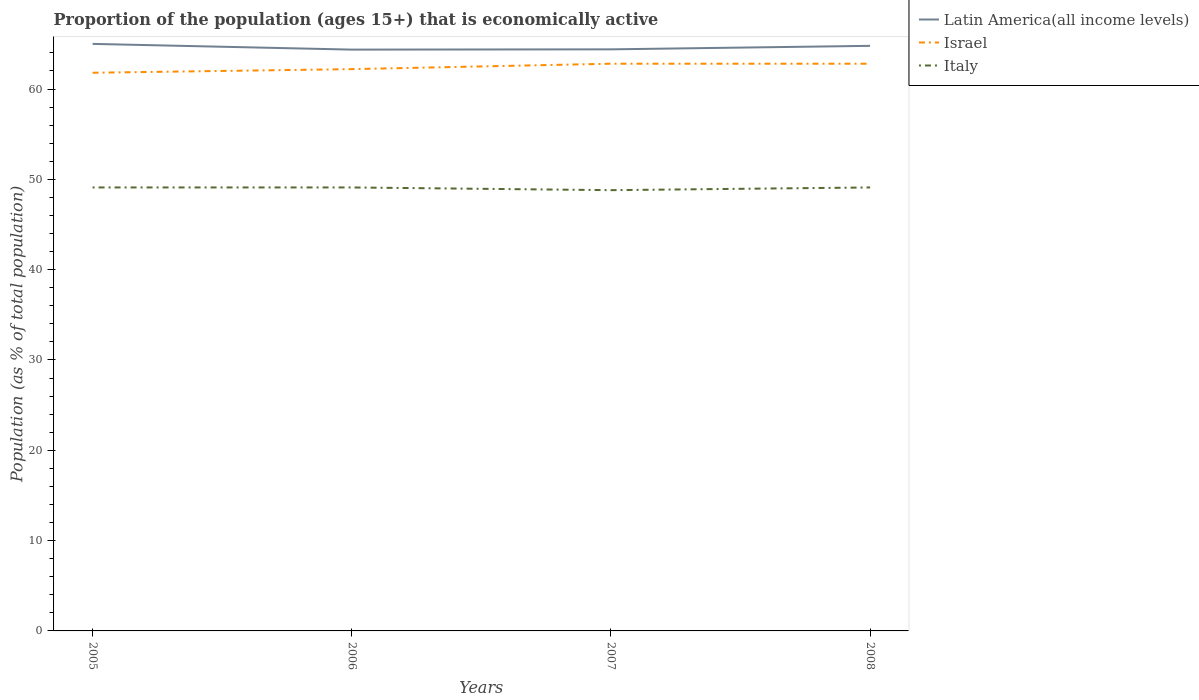Is the number of lines equal to the number of legend labels?
Offer a terse response. Yes. Across all years, what is the maximum proportion of the population that is economically active in Latin America(all income levels)?
Give a very brief answer. 64.36. In which year was the proportion of the population that is economically active in Italy maximum?
Give a very brief answer. 2007. What is the total proportion of the population that is economically active in Israel in the graph?
Give a very brief answer. -0.4. What is the difference between the highest and the second highest proportion of the population that is economically active in Latin America(all income levels)?
Make the answer very short. 0.63. What is the difference between the highest and the lowest proportion of the population that is economically active in Israel?
Provide a short and direct response. 2. What is the difference between two consecutive major ticks on the Y-axis?
Give a very brief answer. 10. Does the graph contain grids?
Your response must be concise. No. Where does the legend appear in the graph?
Give a very brief answer. Top right. How many legend labels are there?
Your answer should be compact. 3. What is the title of the graph?
Your response must be concise. Proportion of the population (ages 15+) that is economically active. Does "Moldova" appear as one of the legend labels in the graph?
Offer a terse response. No. What is the label or title of the Y-axis?
Ensure brevity in your answer.  Population (as % of total population). What is the Population (as % of total population) in Latin America(all income levels) in 2005?
Ensure brevity in your answer.  64.99. What is the Population (as % of total population) in Israel in 2005?
Your response must be concise. 61.8. What is the Population (as % of total population) of Italy in 2005?
Make the answer very short. 49.1. What is the Population (as % of total population) of Latin America(all income levels) in 2006?
Provide a short and direct response. 64.36. What is the Population (as % of total population) of Israel in 2006?
Offer a very short reply. 62.2. What is the Population (as % of total population) in Italy in 2006?
Keep it short and to the point. 49.1. What is the Population (as % of total population) of Latin America(all income levels) in 2007?
Provide a succinct answer. 64.39. What is the Population (as % of total population) in Israel in 2007?
Offer a very short reply. 62.8. What is the Population (as % of total population) in Italy in 2007?
Ensure brevity in your answer.  48.8. What is the Population (as % of total population) in Latin America(all income levels) in 2008?
Make the answer very short. 64.78. What is the Population (as % of total population) in Israel in 2008?
Keep it short and to the point. 62.8. What is the Population (as % of total population) of Italy in 2008?
Your response must be concise. 49.1. Across all years, what is the maximum Population (as % of total population) of Latin America(all income levels)?
Make the answer very short. 64.99. Across all years, what is the maximum Population (as % of total population) in Israel?
Your answer should be very brief. 62.8. Across all years, what is the maximum Population (as % of total population) in Italy?
Your answer should be very brief. 49.1. Across all years, what is the minimum Population (as % of total population) of Latin America(all income levels)?
Keep it short and to the point. 64.36. Across all years, what is the minimum Population (as % of total population) of Israel?
Ensure brevity in your answer.  61.8. Across all years, what is the minimum Population (as % of total population) in Italy?
Your answer should be compact. 48.8. What is the total Population (as % of total population) in Latin America(all income levels) in the graph?
Provide a succinct answer. 258.53. What is the total Population (as % of total population) of Israel in the graph?
Keep it short and to the point. 249.6. What is the total Population (as % of total population) in Italy in the graph?
Make the answer very short. 196.1. What is the difference between the Population (as % of total population) of Latin America(all income levels) in 2005 and that in 2006?
Give a very brief answer. 0.63. What is the difference between the Population (as % of total population) in Latin America(all income levels) in 2005 and that in 2007?
Ensure brevity in your answer.  0.6. What is the difference between the Population (as % of total population) in Latin America(all income levels) in 2005 and that in 2008?
Your response must be concise. 0.22. What is the difference between the Population (as % of total population) in Latin America(all income levels) in 2006 and that in 2007?
Ensure brevity in your answer.  -0.03. What is the difference between the Population (as % of total population) in Israel in 2006 and that in 2007?
Provide a short and direct response. -0.6. What is the difference between the Population (as % of total population) of Latin America(all income levels) in 2006 and that in 2008?
Your answer should be very brief. -0.42. What is the difference between the Population (as % of total population) in Latin America(all income levels) in 2007 and that in 2008?
Keep it short and to the point. -0.39. What is the difference between the Population (as % of total population) in Latin America(all income levels) in 2005 and the Population (as % of total population) in Israel in 2006?
Keep it short and to the point. 2.79. What is the difference between the Population (as % of total population) of Latin America(all income levels) in 2005 and the Population (as % of total population) of Italy in 2006?
Offer a very short reply. 15.89. What is the difference between the Population (as % of total population) in Israel in 2005 and the Population (as % of total population) in Italy in 2006?
Your answer should be very brief. 12.7. What is the difference between the Population (as % of total population) in Latin America(all income levels) in 2005 and the Population (as % of total population) in Israel in 2007?
Your response must be concise. 2.19. What is the difference between the Population (as % of total population) in Latin America(all income levels) in 2005 and the Population (as % of total population) in Italy in 2007?
Keep it short and to the point. 16.2. What is the difference between the Population (as % of total population) in Latin America(all income levels) in 2005 and the Population (as % of total population) in Israel in 2008?
Give a very brief answer. 2.19. What is the difference between the Population (as % of total population) of Latin America(all income levels) in 2005 and the Population (as % of total population) of Italy in 2008?
Give a very brief answer. 15.89. What is the difference between the Population (as % of total population) in Israel in 2005 and the Population (as % of total population) in Italy in 2008?
Make the answer very short. 12.7. What is the difference between the Population (as % of total population) of Latin America(all income levels) in 2006 and the Population (as % of total population) of Israel in 2007?
Make the answer very short. 1.56. What is the difference between the Population (as % of total population) of Latin America(all income levels) in 2006 and the Population (as % of total population) of Italy in 2007?
Your answer should be very brief. 15.56. What is the difference between the Population (as % of total population) of Israel in 2006 and the Population (as % of total population) of Italy in 2007?
Keep it short and to the point. 13.4. What is the difference between the Population (as % of total population) of Latin America(all income levels) in 2006 and the Population (as % of total population) of Israel in 2008?
Your answer should be compact. 1.56. What is the difference between the Population (as % of total population) in Latin America(all income levels) in 2006 and the Population (as % of total population) in Italy in 2008?
Offer a terse response. 15.26. What is the difference between the Population (as % of total population) in Latin America(all income levels) in 2007 and the Population (as % of total population) in Israel in 2008?
Your answer should be very brief. 1.59. What is the difference between the Population (as % of total population) in Latin America(all income levels) in 2007 and the Population (as % of total population) in Italy in 2008?
Ensure brevity in your answer.  15.29. What is the average Population (as % of total population) of Latin America(all income levels) per year?
Your response must be concise. 64.63. What is the average Population (as % of total population) in Israel per year?
Keep it short and to the point. 62.4. What is the average Population (as % of total population) of Italy per year?
Provide a succinct answer. 49.02. In the year 2005, what is the difference between the Population (as % of total population) of Latin America(all income levels) and Population (as % of total population) of Israel?
Give a very brief answer. 3.19. In the year 2005, what is the difference between the Population (as % of total population) of Latin America(all income levels) and Population (as % of total population) of Italy?
Your response must be concise. 15.89. In the year 2005, what is the difference between the Population (as % of total population) of Israel and Population (as % of total population) of Italy?
Offer a terse response. 12.7. In the year 2006, what is the difference between the Population (as % of total population) of Latin America(all income levels) and Population (as % of total population) of Israel?
Provide a short and direct response. 2.16. In the year 2006, what is the difference between the Population (as % of total population) of Latin America(all income levels) and Population (as % of total population) of Italy?
Keep it short and to the point. 15.26. In the year 2006, what is the difference between the Population (as % of total population) in Israel and Population (as % of total population) in Italy?
Provide a short and direct response. 13.1. In the year 2007, what is the difference between the Population (as % of total population) in Latin America(all income levels) and Population (as % of total population) in Israel?
Offer a very short reply. 1.59. In the year 2007, what is the difference between the Population (as % of total population) of Latin America(all income levels) and Population (as % of total population) of Italy?
Your response must be concise. 15.59. In the year 2008, what is the difference between the Population (as % of total population) in Latin America(all income levels) and Population (as % of total population) in Israel?
Your response must be concise. 1.98. In the year 2008, what is the difference between the Population (as % of total population) of Latin America(all income levels) and Population (as % of total population) of Italy?
Provide a short and direct response. 15.68. In the year 2008, what is the difference between the Population (as % of total population) in Israel and Population (as % of total population) in Italy?
Provide a succinct answer. 13.7. What is the ratio of the Population (as % of total population) in Latin America(all income levels) in 2005 to that in 2006?
Provide a short and direct response. 1.01. What is the ratio of the Population (as % of total population) of Israel in 2005 to that in 2006?
Offer a terse response. 0.99. What is the ratio of the Population (as % of total population) in Latin America(all income levels) in 2005 to that in 2007?
Ensure brevity in your answer.  1.01. What is the ratio of the Population (as % of total population) in Israel in 2005 to that in 2007?
Your answer should be very brief. 0.98. What is the ratio of the Population (as % of total population) in Italy in 2005 to that in 2007?
Ensure brevity in your answer.  1.01. What is the ratio of the Population (as % of total population) in Latin America(all income levels) in 2005 to that in 2008?
Keep it short and to the point. 1. What is the ratio of the Population (as % of total population) of Israel in 2005 to that in 2008?
Your response must be concise. 0.98. What is the ratio of the Population (as % of total population) in Italy in 2005 to that in 2008?
Offer a terse response. 1. What is the ratio of the Population (as % of total population) of Israel in 2006 to that in 2008?
Offer a terse response. 0.99. What is the ratio of the Population (as % of total population) of Latin America(all income levels) in 2007 to that in 2008?
Your answer should be very brief. 0.99. What is the ratio of the Population (as % of total population) in Israel in 2007 to that in 2008?
Provide a short and direct response. 1. What is the difference between the highest and the second highest Population (as % of total population) of Latin America(all income levels)?
Provide a short and direct response. 0.22. What is the difference between the highest and the second highest Population (as % of total population) of Israel?
Provide a short and direct response. 0. What is the difference between the highest and the lowest Population (as % of total population) in Latin America(all income levels)?
Your answer should be compact. 0.63. What is the difference between the highest and the lowest Population (as % of total population) of Israel?
Ensure brevity in your answer.  1. What is the difference between the highest and the lowest Population (as % of total population) of Italy?
Give a very brief answer. 0.3. 